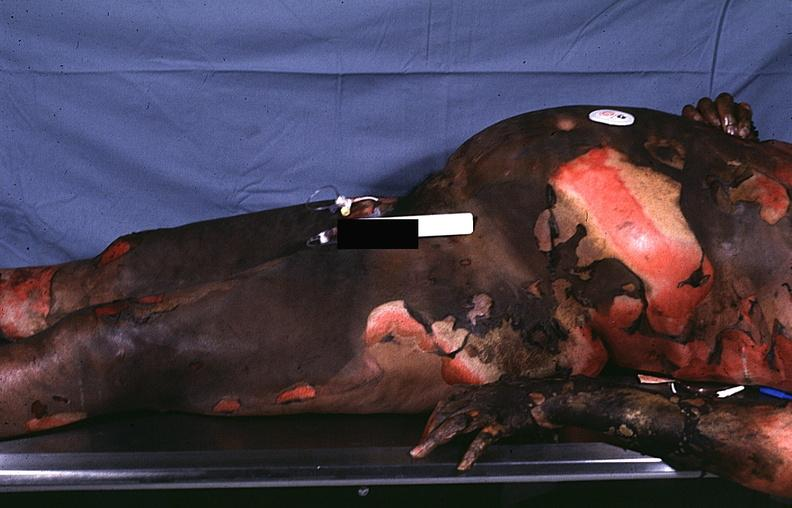what does this image show?
Answer the question using a single word or phrase. Thermal burn 